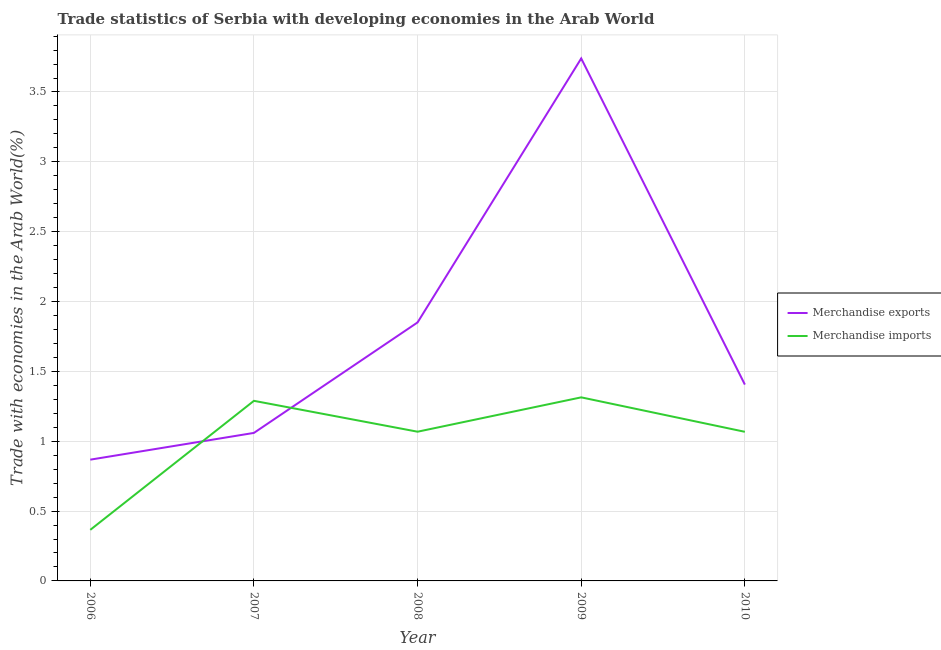Does the line corresponding to merchandise exports intersect with the line corresponding to merchandise imports?
Keep it short and to the point. Yes. Is the number of lines equal to the number of legend labels?
Provide a short and direct response. Yes. What is the merchandise exports in 2006?
Make the answer very short. 0.87. Across all years, what is the maximum merchandise imports?
Provide a succinct answer. 1.31. Across all years, what is the minimum merchandise exports?
Give a very brief answer. 0.87. In which year was the merchandise imports minimum?
Keep it short and to the point. 2006. What is the total merchandise exports in the graph?
Ensure brevity in your answer.  8.92. What is the difference between the merchandise imports in 2007 and that in 2008?
Give a very brief answer. 0.22. What is the difference between the merchandise exports in 2010 and the merchandise imports in 2007?
Provide a succinct answer. 0.12. What is the average merchandise exports per year?
Offer a very short reply. 1.78. In the year 2006, what is the difference between the merchandise imports and merchandise exports?
Give a very brief answer. -0.5. What is the ratio of the merchandise imports in 2007 to that in 2008?
Keep it short and to the point. 1.21. What is the difference between the highest and the second highest merchandise imports?
Offer a very short reply. 0.02. What is the difference between the highest and the lowest merchandise exports?
Make the answer very short. 2.87. In how many years, is the merchandise exports greater than the average merchandise exports taken over all years?
Ensure brevity in your answer.  2. Does the merchandise imports monotonically increase over the years?
Ensure brevity in your answer.  No. Is the merchandise exports strictly greater than the merchandise imports over the years?
Give a very brief answer. No. What is the difference between two consecutive major ticks on the Y-axis?
Ensure brevity in your answer.  0.5. Does the graph contain any zero values?
Ensure brevity in your answer.  No. Does the graph contain grids?
Your response must be concise. Yes. What is the title of the graph?
Ensure brevity in your answer.  Trade statistics of Serbia with developing economies in the Arab World. What is the label or title of the X-axis?
Make the answer very short. Year. What is the label or title of the Y-axis?
Your answer should be very brief. Trade with economies in the Arab World(%). What is the Trade with economies in the Arab World(%) of Merchandise exports in 2006?
Make the answer very short. 0.87. What is the Trade with economies in the Arab World(%) in Merchandise imports in 2006?
Make the answer very short. 0.37. What is the Trade with economies in the Arab World(%) of Merchandise exports in 2007?
Your response must be concise. 1.06. What is the Trade with economies in the Arab World(%) of Merchandise imports in 2007?
Your response must be concise. 1.29. What is the Trade with economies in the Arab World(%) in Merchandise exports in 2008?
Make the answer very short. 1.85. What is the Trade with economies in the Arab World(%) of Merchandise imports in 2008?
Give a very brief answer. 1.07. What is the Trade with economies in the Arab World(%) of Merchandise exports in 2009?
Give a very brief answer. 3.74. What is the Trade with economies in the Arab World(%) in Merchandise imports in 2009?
Offer a very short reply. 1.31. What is the Trade with economies in the Arab World(%) of Merchandise exports in 2010?
Provide a succinct answer. 1.41. What is the Trade with economies in the Arab World(%) in Merchandise imports in 2010?
Your answer should be very brief. 1.07. Across all years, what is the maximum Trade with economies in the Arab World(%) of Merchandise exports?
Provide a succinct answer. 3.74. Across all years, what is the maximum Trade with economies in the Arab World(%) of Merchandise imports?
Give a very brief answer. 1.31. Across all years, what is the minimum Trade with economies in the Arab World(%) in Merchandise exports?
Ensure brevity in your answer.  0.87. Across all years, what is the minimum Trade with economies in the Arab World(%) in Merchandise imports?
Your response must be concise. 0.37. What is the total Trade with economies in the Arab World(%) of Merchandise exports in the graph?
Ensure brevity in your answer.  8.92. What is the total Trade with economies in the Arab World(%) of Merchandise imports in the graph?
Keep it short and to the point. 5.1. What is the difference between the Trade with economies in the Arab World(%) in Merchandise exports in 2006 and that in 2007?
Your response must be concise. -0.19. What is the difference between the Trade with economies in the Arab World(%) in Merchandise imports in 2006 and that in 2007?
Offer a terse response. -0.92. What is the difference between the Trade with economies in the Arab World(%) in Merchandise exports in 2006 and that in 2008?
Keep it short and to the point. -0.98. What is the difference between the Trade with economies in the Arab World(%) in Merchandise imports in 2006 and that in 2008?
Offer a very short reply. -0.7. What is the difference between the Trade with economies in the Arab World(%) of Merchandise exports in 2006 and that in 2009?
Provide a succinct answer. -2.87. What is the difference between the Trade with economies in the Arab World(%) in Merchandise imports in 2006 and that in 2009?
Provide a short and direct response. -0.95. What is the difference between the Trade with economies in the Arab World(%) of Merchandise exports in 2006 and that in 2010?
Keep it short and to the point. -0.54. What is the difference between the Trade with economies in the Arab World(%) of Merchandise imports in 2006 and that in 2010?
Make the answer very short. -0.7. What is the difference between the Trade with economies in the Arab World(%) in Merchandise exports in 2007 and that in 2008?
Ensure brevity in your answer.  -0.79. What is the difference between the Trade with economies in the Arab World(%) in Merchandise imports in 2007 and that in 2008?
Make the answer very short. 0.22. What is the difference between the Trade with economies in the Arab World(%) in Merchandise exports in 2007 and that in 2009?
Offer a terse response. -2.68. What is the difference between the Trade with economies in the Arab World(%) of Merchandise imports in 2007 and that in 2009?
Offer a terse response. -0.02. What is the difference between the Trade with economies in the Arab World(%) of Merchandise exports in 2007 and that in 2010?
Offer a very short reply. -0.35. What is the difference between the Trade with economies in the Arab World(%) in Merchandise imports in 2007 and that in 2010?
Offer a terse response. 0.22. What is the difference between the Trade with economies in the Arab World(%) of Merchandise exports in 2008 and that in 2009?
Offer a terse response. -1.89. What is the difference between the Trade with economies in the Arab World(%) in Merchandise imports in 2008 and that in 2009?
Your response must be concise. -0.25. What is the difference between the Trade with economies in the Arab World(%) in Merchandise exports in 2008 and that in 2010?
Give a very brief answer. 0.44. What is the difference between the Trade with economies in the Arab World(%) in Merchandise imports in 2008 and that in 2010?
Offer a very short reply. 0. What is the difference between the Trade with economies in the Arab World(%) in Merchandise exports in 2009 and that in 2010?
Make the answer very short. 2.33. What is the difference between the Trade with economies in the Arab World(%) in Merchandise imports in 2009 and that in 2010?
Provide a succinct answer. 0.25. What is the difference between the Trade with economies in the Arab World(%) of Merchandise exports in 2006 and the Trade with economies in the Arab World(%) of Merchandise imports in 2007?
Make the answer very short. -0.42. What is the difference between the Trade with economies in the Arab World(%) in Merchandise exports in 2006 and the Trade with economies in the Arab World(%) in Merchandise imports in 2008?
Make the answer very short. -0.2. What is the difference between the Trade with economies in the Arab World(%) in Merchandise exports in 2006 and the Trade with economies in the Arab World(%) in Merchandise imports in 2009?
Ensure brevity in your answer.  -0.45. What is the difference between the Trade with economies in the Arab World(%) in Merchandise exports in 2006 and the Trade with economies in the Arab World(%) in Merchandise imports in 2010?
Your answer should be very brief. -0.2. What is the difference between the Trade with economies in the Arab World(%) in Merchandise exports in 2007 and the Trade with economies in the Arab World(%) in Merchandise imports in 2008?
Ensure brevity in your answer.  -0.01. What is the difference between the Trade with economies in the Arab World(%) in Merchandise exports in 2007 and the Trade with economies in the Arab World(%) in Merchandise imports in 2009?
Give a very brief answer. -0.25. What is the difference between the Trade with economies in the Arab World(%) in Merchandise exports in 2007 and the Trade with economies in the Arab World(%) in Merchandise imports in 2010?
Make the answer very short. -0.01. What is the difference between the Trade with economies in the Arab World(%) of Merchandise exports in 2008 and the Trade with economies in the Arab World(%) of Merchandise imports in 2009?
Your answer should be very brief. 0.54. What is the difference between the Trade with economies in the Arab World(%) of Merchandise exports in 2008 and the Trade with economies in the Arab World(%) of Merchandise imports in 2010?
Provide a succinct answer. 0.78. What is the difference between the Trade with economies in the Arab World(%) in Merchandise exports in 2009 and the Trade with economies in the Arab World(%) in Merchandise imports in 2010?
Provide a succinct answer. 2.67. What is the average Trade with economies in the Arab World(%) of Merchandise exports per year?
Offer a terse response. 1.78. What is the average Trade with economies in the Arab World(%) of Merchandise imports per year?
Your answer should be compact. 1.02. In the year 2006, what is the difference between the Trade with economies in the Arab World(%) of Merchandise exports and Trade with economies in the Arab World(%) of Merchandise imports?
Your answer should be compact. 0.5. In the year 2007, what is the difference between the Trade with economies in the Arab World(%) of Merchandise exports and Trade with economies in the Arab World(%) of Merchandise imports?
Keep it short and to the point. -0.23. In the year 2008, what is the difference between the Trade with economies in the Arab World(%) of Merchandise exports and Trade with economies in the Arab World(%) of Merchandise imports?
Your answer should be compact. 0.78. In the year 2009, what is the difference between the Trade with economies in the Arab World(%) of Merchandise exports and Trade with economies in the Arab World(%) of Merchandise imports?
Your answer should be very brief. 2.43. In the year 2010, what is the difference between the Trade with economies in the Arab World(%) in Merchandise exports and Trade with economies in the Arab World(%) in Merchandise imports?
Provide a short and direct response. 0.34. What is the ratio of the Trade with economies in the Arab World(%) of Merchandise exports in 2006 to that in 2007?
Give a very brief answer. 0.82. What is the ratio of the Trade with economies in the Arab World(%) in Merchandise imports in 2006 to that in 2007?
Your answer should be compact. 0.28. What is the ratio of the Trade with economies in the Arab World(%) of Merchandise exports in 2006 to that in 2008?
Your answer should be compact. 0.47. What is the ratio of the Trade with economies in the Arab World(%) in Merchandise imports in 2006 to that in 2008?
Provide a succinct answer. 0.34. What is the ratio of the Trade with economies in the Arab World(%) in Merchandise exports in 2006 to that in 2009?
Give a very brief answer. 0.23. What is the ratio of the Trade with economies in the Arab World(%) in Merchandise imports in 2006 to that in 2009?
Your answer should be very brief. 0.28. What is the ratio of the Trade with economies in the Arab World(%) in Merchandise exports in 2006 to that in 2010?
Provide a succinct answer. 0.62. What is the ratio of the Trade with economies in the Arab World(%) in Merchandise imports in 2006 to that in 2010?
Provide a succinct answer. 0.34. What is the ratio of the Trade with economies in the Arab World(%) of Merchandise exports in 2007 to that in 2008?
Provide a succinct answer. 0.57. What is the ratio of the Trade with economies in the Arab World(%) in Merchandise imports in 2007 to that in 2008?
Ensure brevity in your answer.  1.21. What is the ratio of the Trade with economies in the Arab World(%) of Merchandise exports in 2007 to that in 2009?
Your response must be concise. 0.28. What is the ratio of the Trade with economies in the Arab World(%) in Merchandise imports in 2007 to that in 2009?
Make the answer very short. 0.98. What is the ratio of the Trade with economies in the Arab World(%) of Merchandise exports in 2007 to that in 2010?
Keep it short and to the point. 0.75. What is the ratio of the Trade with economies in the Arab World(%) in Merchandise imports in 2007 to that in 2010?
Your response must be concise. 1.21. What is the ratio of the Trade with economies in the Arab World(%) in Merchandise exports in 2008 to that in 2009?
Offer a very short reply. 0.49. What is the ratio of the Trade with economies in the Arab World(%) of Merchandise imports in 2008 to that in 2009?
Offer a very short reply. 0.81. What is the ratio of the Trade with economies in the Arab World(%) of Merchandise exports in 2008 to that in 2010?
Give a very brief answer. 1.32. What is the ratio of the Trade with economies in the Arab World(%) in Merchandise imports in 2008 to that in 2010?
Provide a succinct answer. 1. What is the ratio of the Trade with economies in the Arab World(%) of Merchandise exports in 2009 to that in 2010?
Give a very brief answer. 2.66. What is the ratio of the Trade with economies in the Arab World(%) in Merchandise imports in 2009 to that in 2010?
Keep it short and to the point. 1.23. What is the difference between the highest and the second highest Trade with economies in the Arab World(%) in Merchandise exports?
Offer a terse response. 1.89. What is the difference between the highest and the second highest Trade with economies in the Arab World(%) of Merchandise imports?
Your answer should be very brief. 0.02. What is the difference between the highest and the lowest Trade with economies in the Arab World(%) of Merchandise exports?
Keep it short and to the point. 2.87. What is the difference between the highest and the lowest Trade with economies in the Arab World(%) in Merchandise imports?
Give a very brief answer. 0.95. 